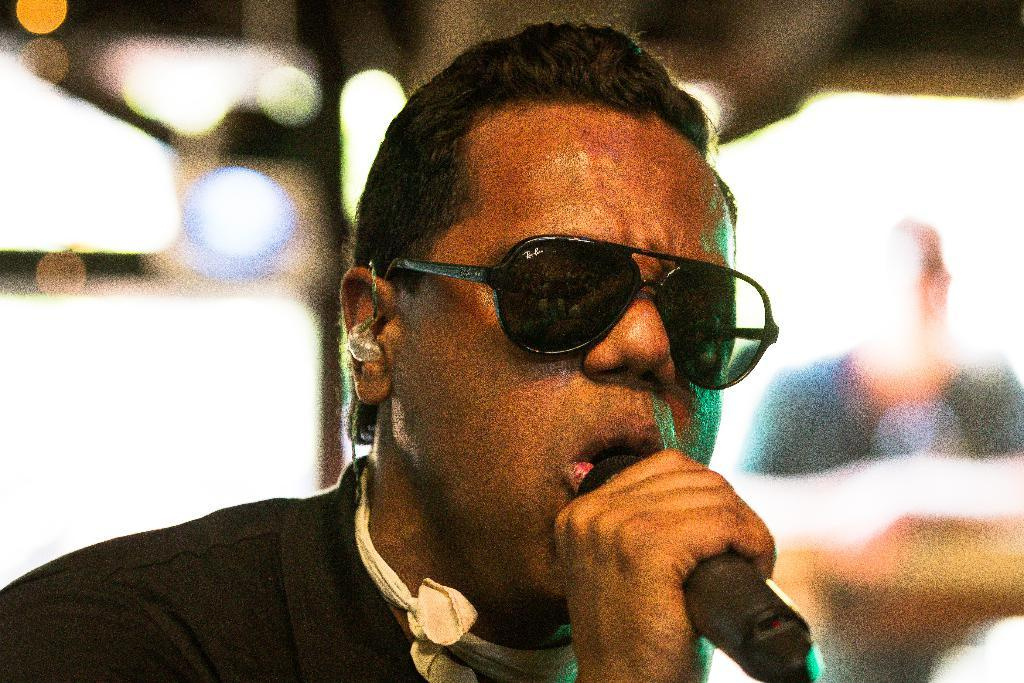Who is the main subject in the image? There is a man in the image. What is the man wearing? The man is wearing goggles. What is the man doing in the image? The man is singing. What object is in front of the man? There is a microphone in front of the man. Can you describe the background of the image? The background of the image is blurred. What idea did the company come up with for the new product launch? There is no mention of a company or a new product launch in the image, so it is not possible to answer that question. 